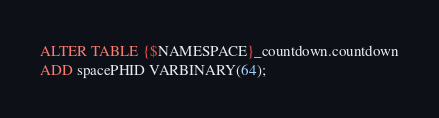<code> <loc_0><loc_0><loc_500><loc_500><_SQL_>ALTER TABLE {$NAMESPACE}_countdown.countdown
ADD spacePHID VARBINARY(64);
</code> 